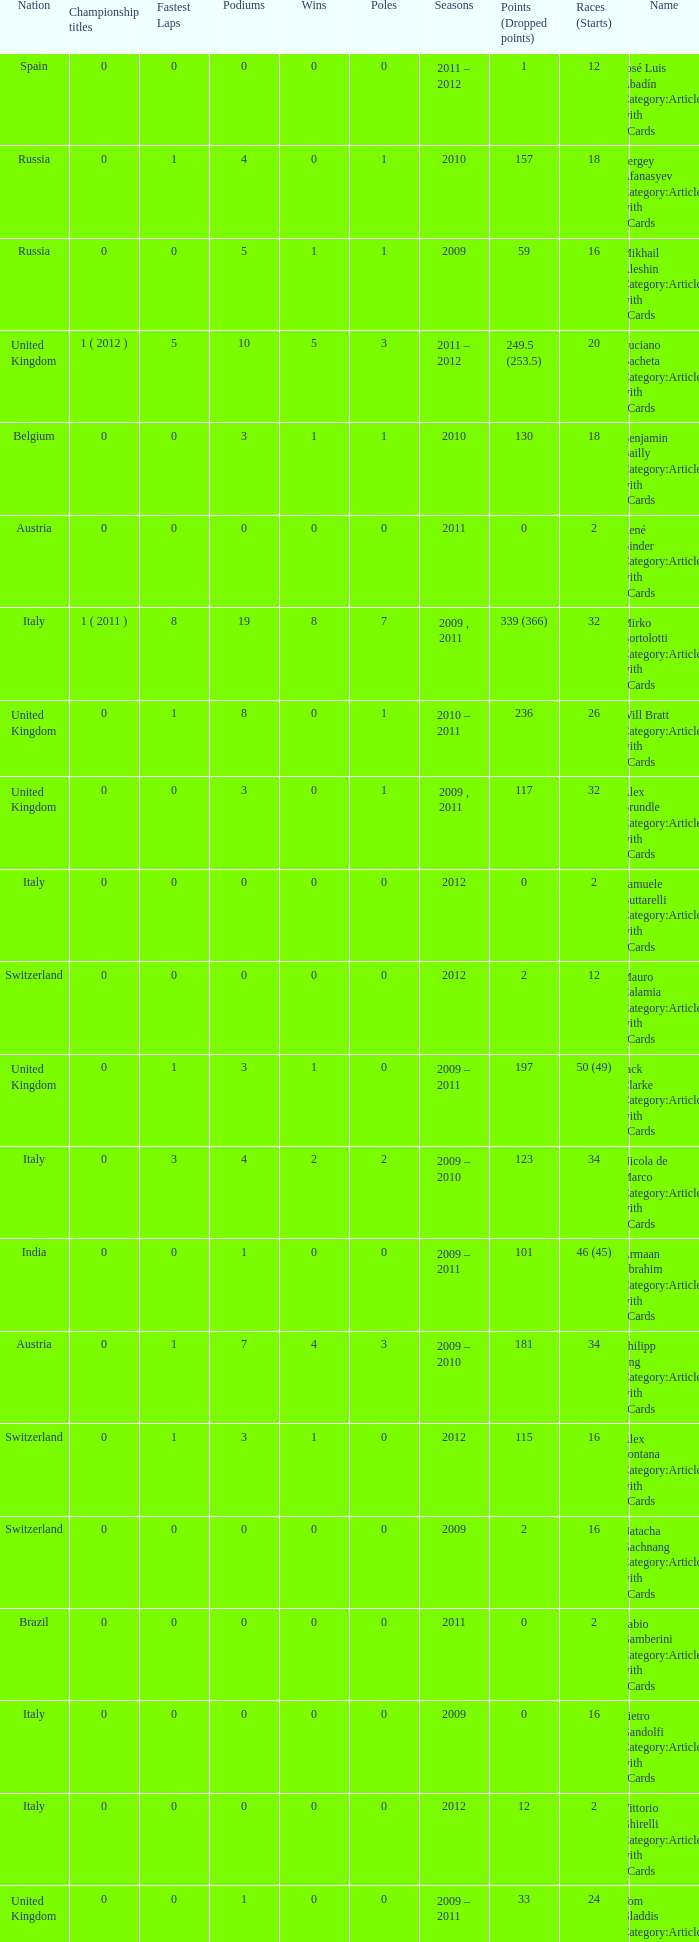What were the starts when the points dropped 18? 8.0. 